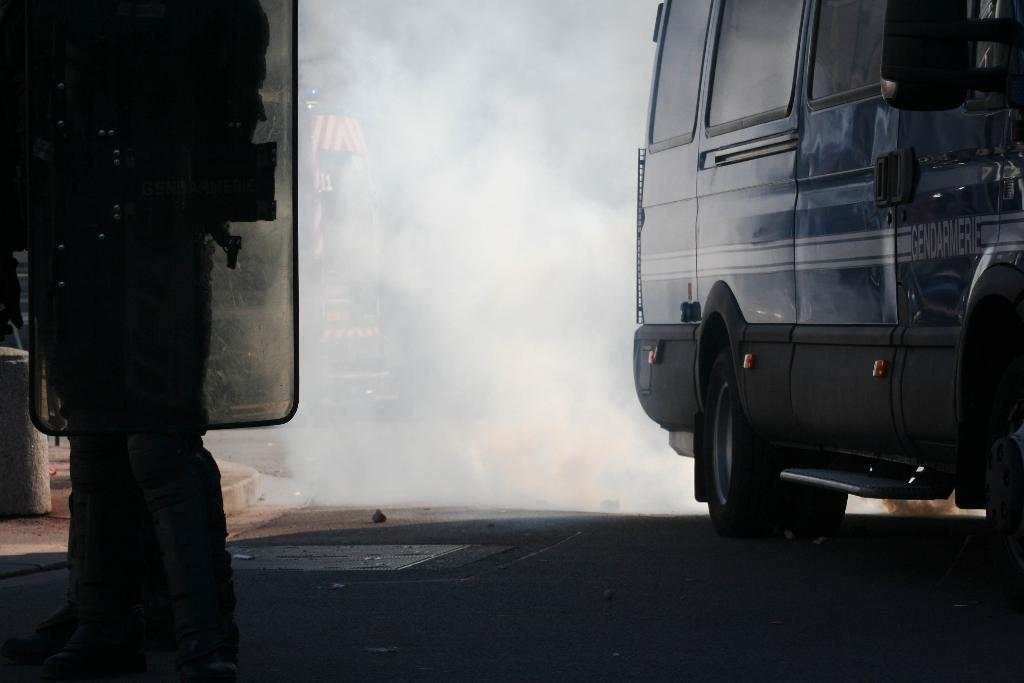What is on the road in the image? There is a vehicle on the road in the image. Can you describe the person in the image? There is a person standing in the image. What can be seen in the air in the image? There is smoke visible in the image. What type of fruit is being shaken in the image? There is no fruit present in the image, nor is there any indication of shaking. 